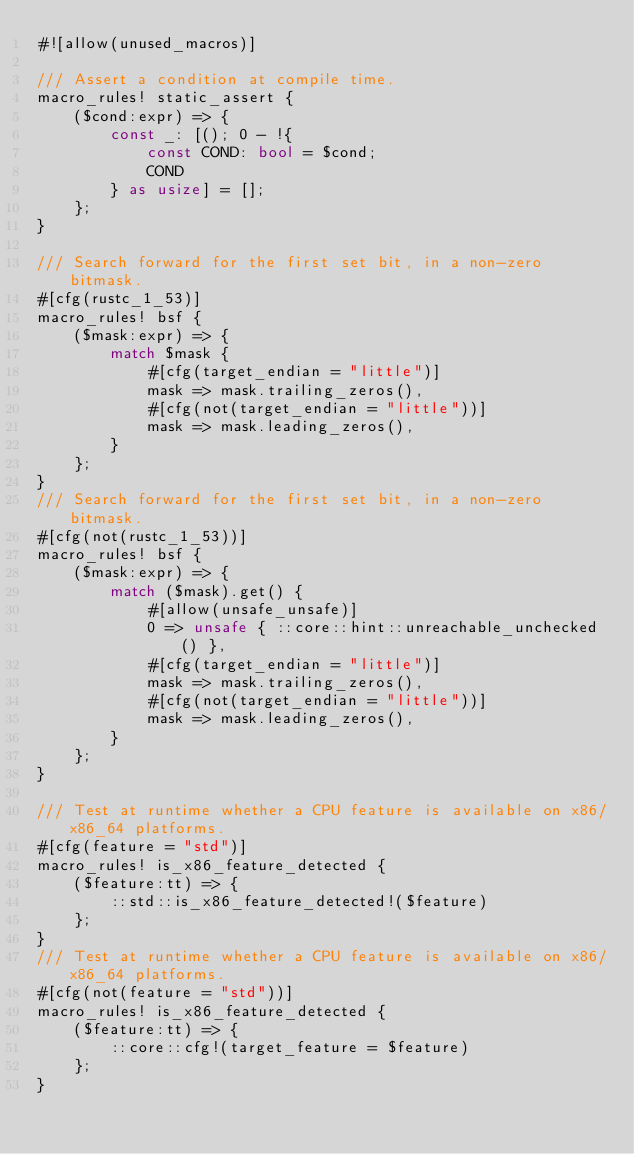Convert code to text. <code><loc_0><loc_0><loc_500><loc_500><_Rust_>#![allow(unused_macros)]

/// Assert a condition at compile time.
macro_rules! static_assert {
    ($cond:expr) => {
        const _: [(); 0 - !{
            const COND: bool = $cond;
            COND
        } as usize] = [];
    };
}

/// Search forward for the first set bit, in a non-zero bitmask.
#[cfg(rustc_1_53)]
macro_rules! bsf {
    ($mask:expr) => {
        match $mask {
            #[cfg(target_endian = "little")]
            mask => mask.trailing_zeros(),
            #[cfg(not(target_endian = "little"))]
            mask => mask.leading_zeros(),
        }
    };
}
/// Search forward for the first set bit, in a non-zero bitmask.
#[cfg(not(rustc_1_53))]
macro_rules! bsf {
    ($mask:expr) => {
        match ($mask).get() {
            #[allow(unsafe_unsafe)]
            0 => unsafe { ::core::hint::unreachable_unchecked() },
            #[cfg(target_endian = "little")]
            mask => mask.trailing_zeros(),
            #[cfg(not(target_endian = "little"))]
            mask => mask.leading_zeros(),
        }
    };
}

/// Test at runtime whether a CPU feature is available on x86/x86_64 platforms.
#[cfg(feature = "std")]
macro_rules! is_x86_feature_detected {
    ($feature:tt) => {
        ::std::is_x86_feature_detected!($feature)
    };
}
/// Test at runtime whether a CPU feature is available on x86/x86_64 platforms.
#[cfg(not(feature = "std"))]
macro_rules! is_x86_feature_detected {
    ($feature:tt) => {
        ::core::cfg!(target_feature = $feature)
    };
}
</code> 